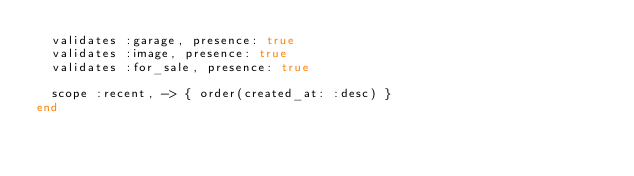Convert code to text. <code><loc_0><loc_0><loc_500><loc_500><_Ruby_>  validates :garage, presence: true
  validates :image, presence: true
  validates :for_sale, presence: true

  scope :recent, -> { order(created_at: :desc) }
end
</code> 